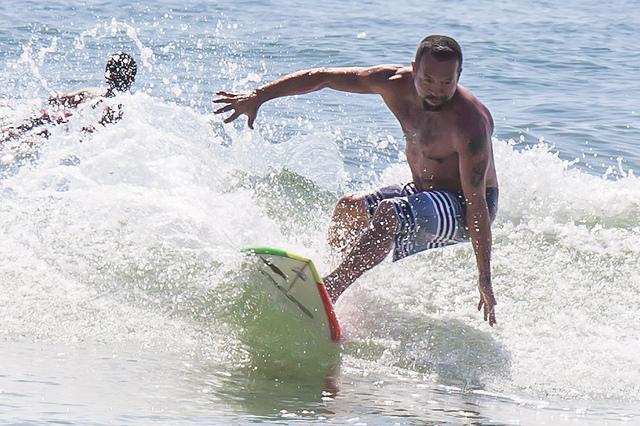How many people are visible?
Give a very brief answer. 2. How many of the bears legs are bent?
Give a very brief answer. 0. 